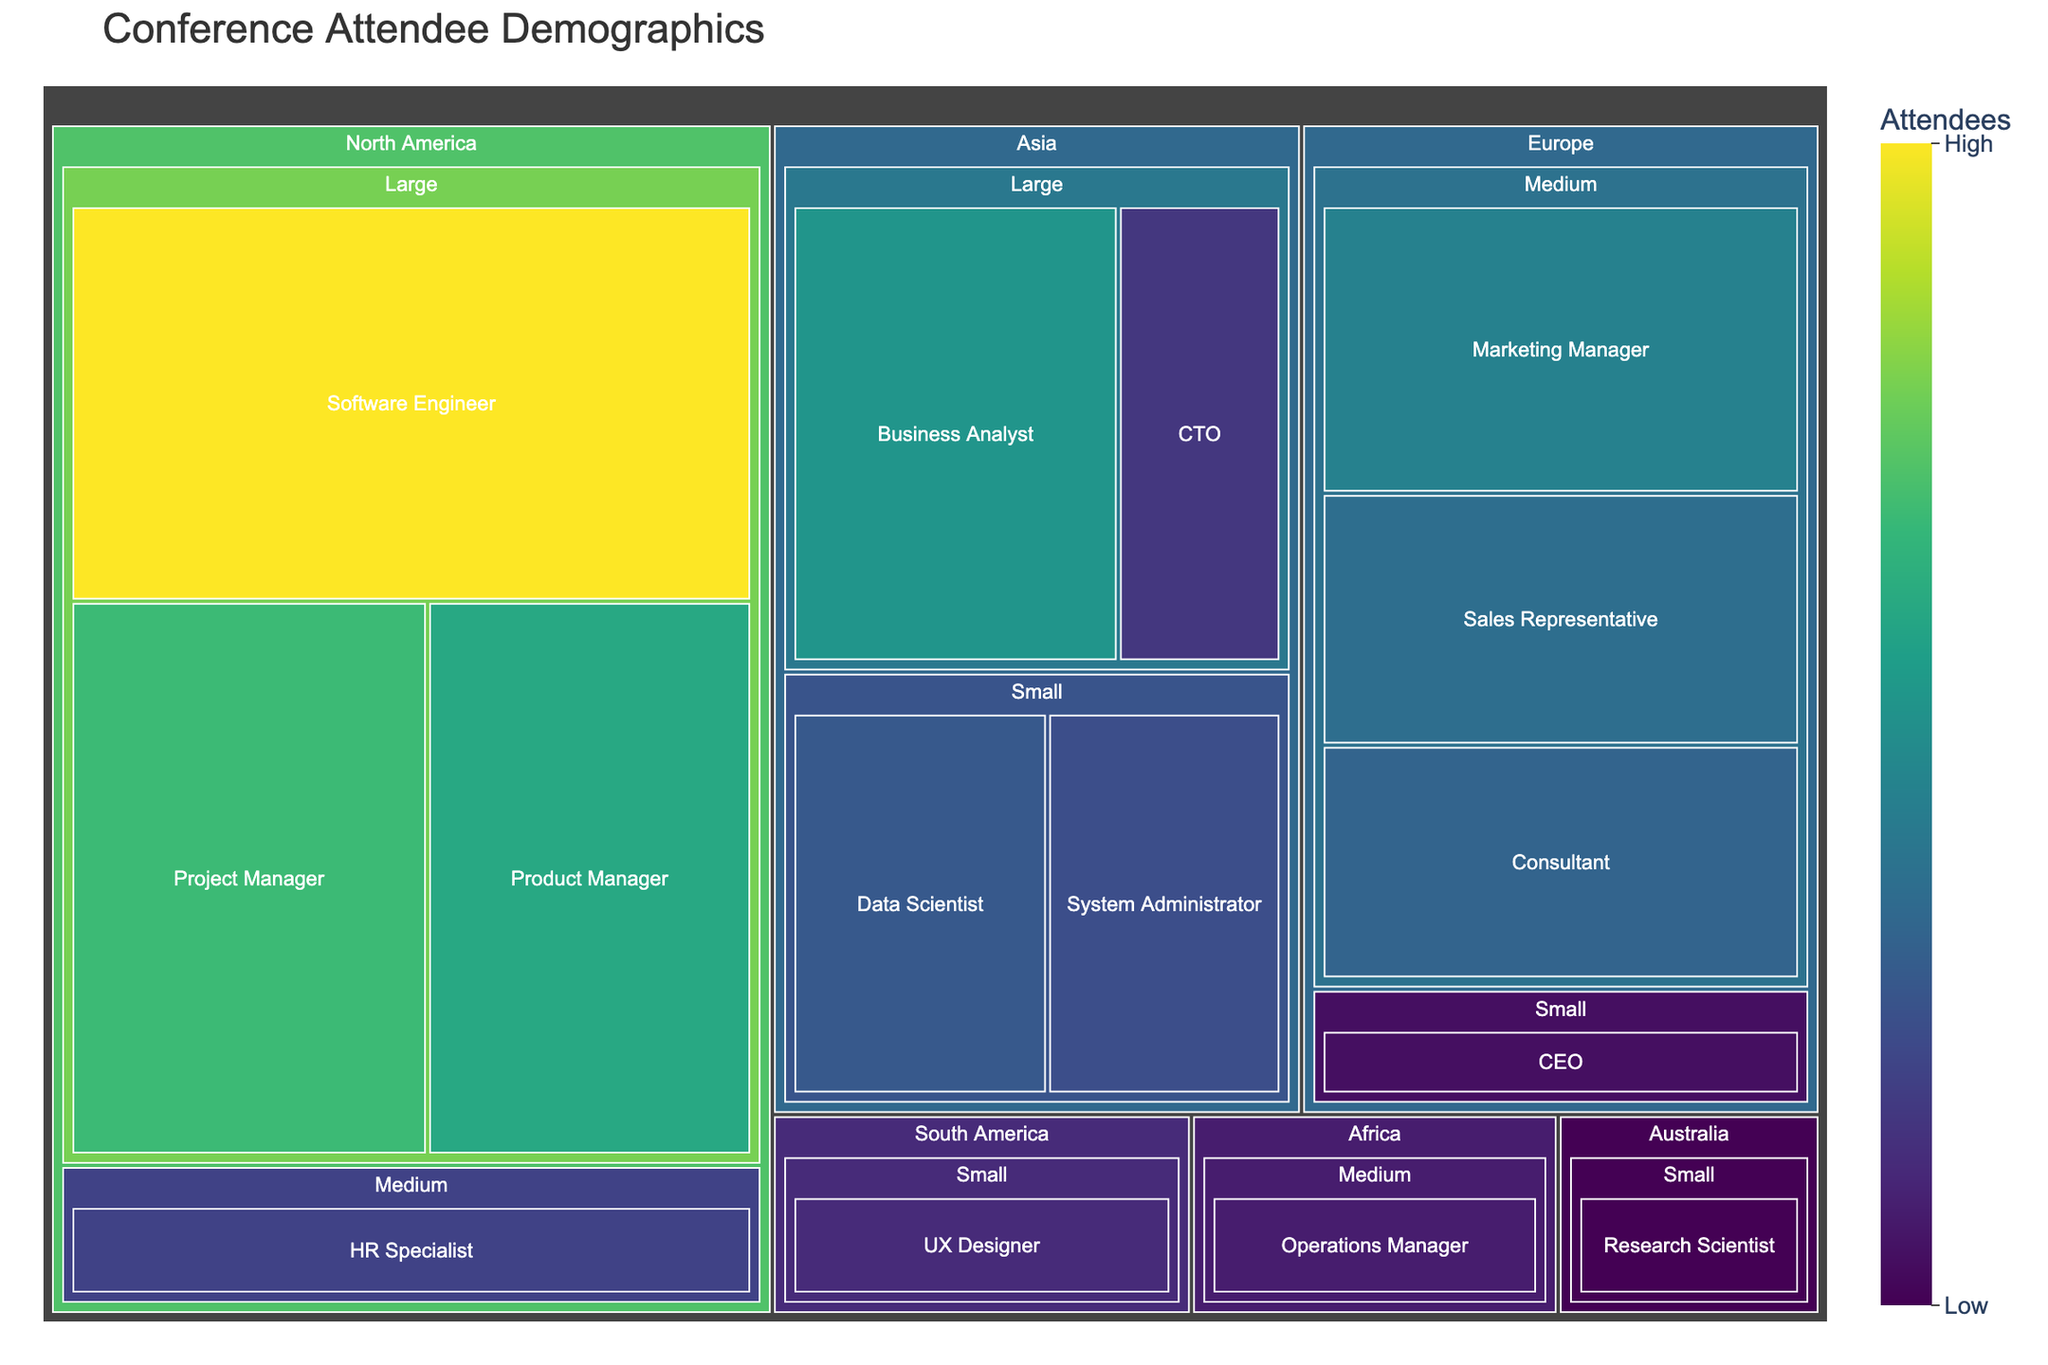What is the largest attendee group by job title and company size in North America? To find the largest attendee group by job title and company size in North America, look at the North America region in the treemap and identify the group with the highest number of attendees. The Software Engineer group at Large companies has 150 attendees, which is the highest in this region.
Answer: Software Engineer at Large companies How many attendees are there in the Europe region? Sum the attendees for all the job titles and company sizes under the Europe region in the treemap. The attendees are 80 (Marketing Manager, Medium), 70 (Sales Representative, Medium), 30 (CEO, Small), and 65 (Consultant, Medium), giving a total of 80 + 70 + 30 + 65 = 245.
Answer: 245 Which job title in the Asia region has the least attendees? Within the Asia region, compare the attendee numbers for each job title. The job title with the least attendees is CTO at Large companies with 45 attendees.
Answer: CTO at Large companies Are there more attendees in North America or Europe? Sum the total number of attendees in the North America region and compare it with the total number of attendees in the Europe region. North America has 150 (Software Engineer), 100 (Product Manager), 50 (HR Specialist), 110 (Project Manager) = 410 attendees. Europe has 80 (Marketing Manager), 70 (Sales Representative), 30 (CEO), 65 (Consultant) = 245 attendees. North America has more attendees.
Answer: North America What is the sum of attendees for Small companies across all regions? Sum the attendees for Small companies across all regions: 60 (Data Scientist in Asia), 40 (UX Designer in South America), 30 (CEO in Europe), 25 (Research Scientist in Australia), and 55 (System Administrator in Asia). The total is 60 + 40 + 30 + 25 + 55 = 210.
Answer: 210 Which region has the most attendees? Compare the total number of attendees in each region. North America has 410, Europe has 245, Asia has 150 (Software Engineer), 90 (Business Analyst), 45 (CTO), 55 (System Administrator) = 240, South America has 40, and Australia has 25. North America has the most attendees.
Answer: North America What is the average number of attendees for Medium-sized companies across all regions? Calculate the sum of attendees for Medium-sized companies and divide by the number of Medium-sized job title groups: 80 (Marketing Manager in Europe), 70 (Sales Representative in Europe), 50 (HR Specialist in North America), and 35 (Operations Manager in Africa), 65 (Consultant in Europe). The sum is 80 + 70 + 50 + 35 + 65 = 300. There are 5 groups, so the average is 300 / 5 = 60.
Answer: 60 Which job title among Large companies in North America has the second highest number of attendees? Identify the job titles in North America for Large companies and sort them by number of attendees. The titles and numbers are 150 (Software Engineer), 100 (Product Manager), and 110 (Project Manager). The second highest is Project Manager with 110 attendees.
Answer: Project Manager How many regions have at least one Small company attendee? Count the number of regions in the treemap where there is at least one group from a Small company. The regions are Asia (Data Scientist, System Administrator), South America (UX Designer), Europe (CEO), and Australia (Research Scientist) totaling to 4.
Answer: 4 